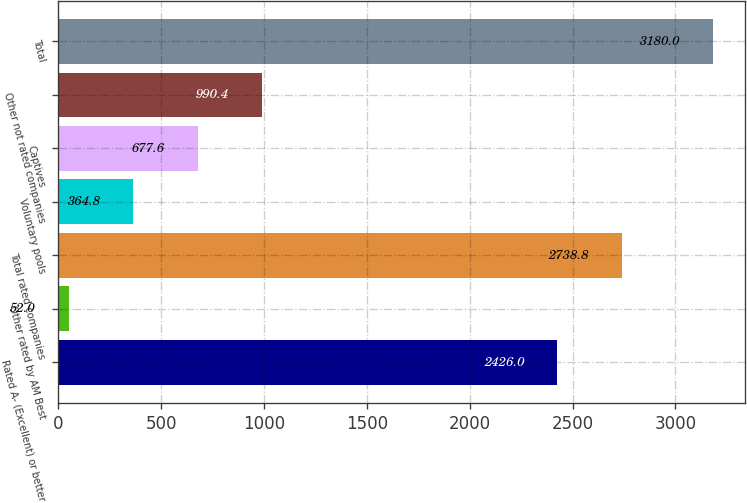<chart> <loc_0><loc_0><loc_500><loc_500><bar_chart><fcel>Rated A- (Excellent) or better<fcel>Other rated by AM Best<fcel>Total rated companies<fcel>Voluntary pools<fcel>Captives<fcel>Other not rated companies<fcel>Total<nl><fcel>2426<fcel>52<fcel>2738.8<fcel>364.8<fcel>677.6<fcel>990.4<fcel>3180<nl></chart> 